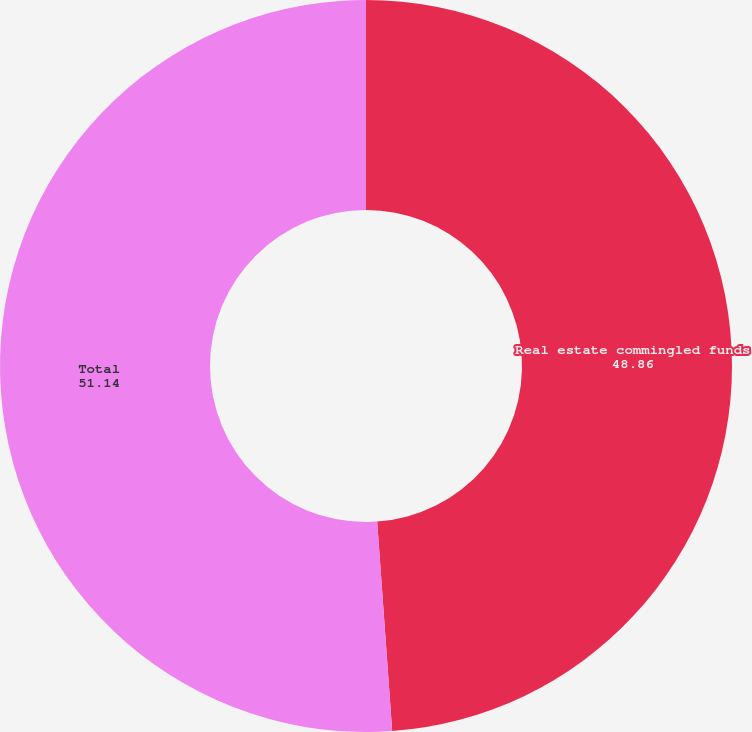Convert chart to OTSL. <chart><loc_0><loc_0><loc_500><loc_500><pie_chart><fcel>Real estate commingled funds<fcel>Total<nl><fcel>48.86%<fcel>51.14%<nl></chart> 